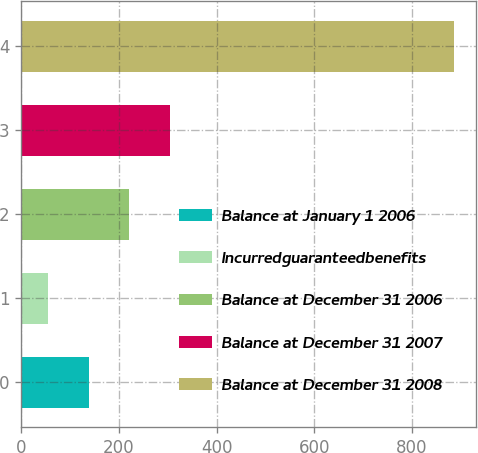Convert chart. <chart><loc_0><loc_0><loc_500><loc_500><bar_chart><fcel>Balance at January 1 2006<fcel>Incurredguaranteedbenefits<fcel>Balance at December 31 2006<fcel>Balance at December 31 2007<fcel>Balance at December 31 2008<nl><fcel>138.2<fcel>55<fcel>221.4<fcel>304.6<fcel>887<nl></chart> 